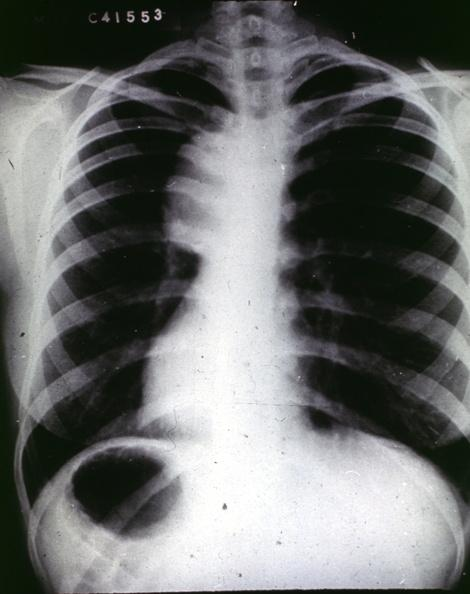where is this from?
Answer the question using a single word or phrase. Aorta 